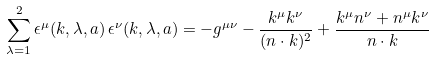Convert formula to latex. <formula><loc_0><loc_0><loc_500><loc_500>\sum _ { \lambda = 1 } ^ { 2 } \epsilon ^ { \mu } ( { k } , \lambda , a ) \, \epsilon ^ { \nu } ( { k } , \lambda , a ) = - g ^ { \mu \nu } - \frac { k ^ { \mu } k ^ { \nu } } { ( n \cdot k ) ^ { 2 } } + \frac { k ^ { \mu } n ^ { \nu } + n ^ { \mu } k ^ { \nu } } { n \cdot k }</formula> 